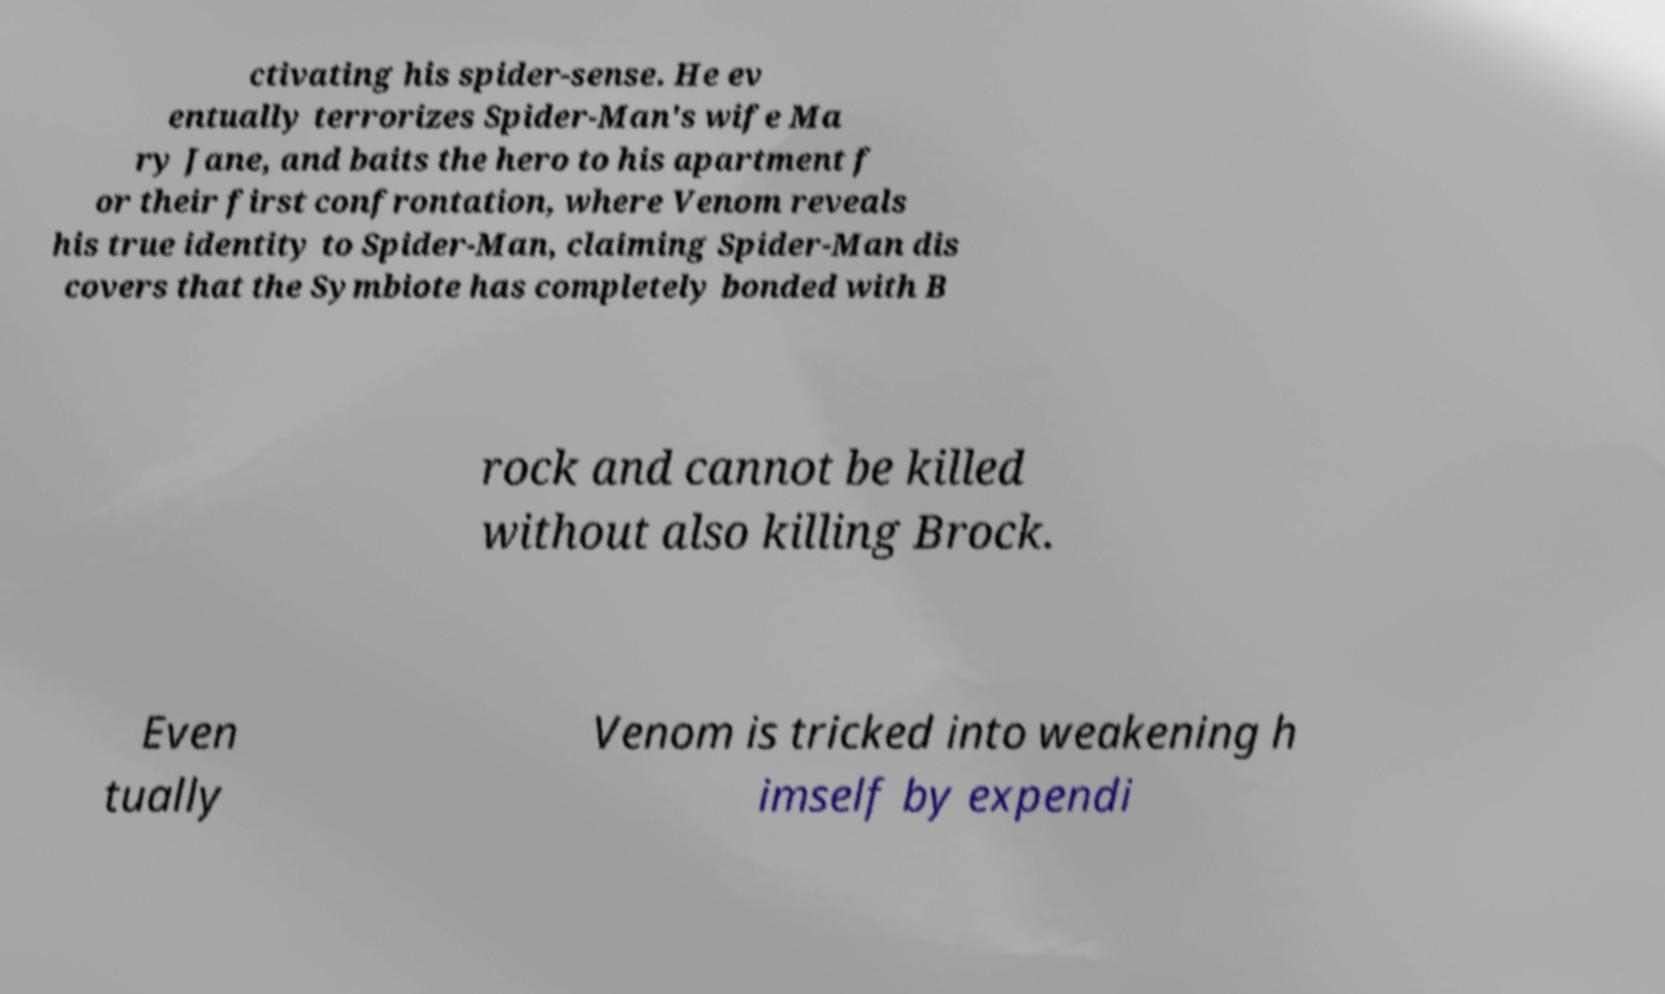For documentation purposes, I need the text within this image transcribed. Could you provide that? ctivating his spider-sense. He ev entually terrorizes Spider-Man's wife Ma ry Jane, and baits the hero to his apartment f or their first confrontation, where Venom reveals his true identity to Spider-Man, claiming Spider-Man dis covers that the Symbiote has completely bonded with B rock and cannot be killed without also killing Brock. Even tually Venom is tricked into weakening h imself by expendi 